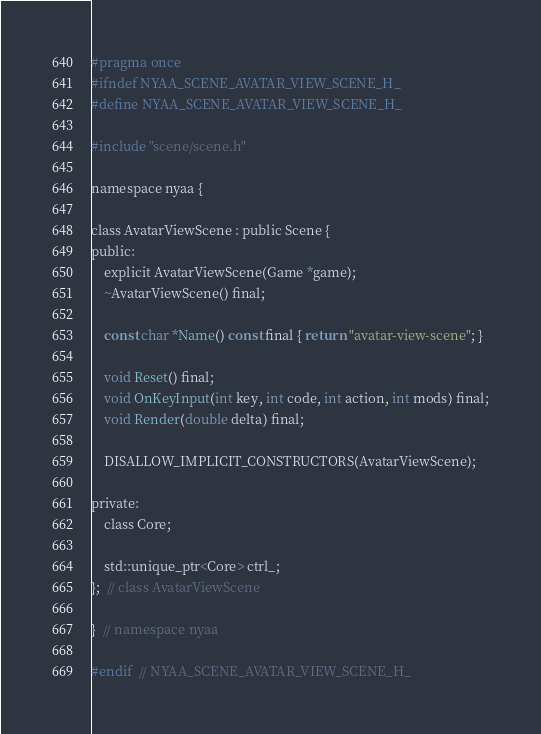<code> <loc_0><loc_0><loc_500><loc_500><_C_>#pragma once
#ifndef NYAA_SCENE_AVATAR_VIEW_SCENE_H_
#define NYAA_SCENE_AVATAR_VIEW_SCENE_H_

#include "scene/scene.h"

namespace nyaa {

class AvatarViewScene : public Scene {
public:
    explicit AvatarViewScene(Game *game);
    ~AvatarViewScene() final;

    const char *Name() const final { return "avatar-view-scene"; }

    void Reset() final;
    void OnKeyInput(int key, int code, int action, int mods) final;
    void Render(double delta) final;

    DISALLOW_IMPLICIT_CONSTRUCTORS(AvatarViewScene);

private:
    class Core;

    std::unique_ptr<Core> ctrl_;
};  // class AvatarViewScene

}  // namespace nyaa

#endif  // NYAA_SCENE_AVATAR_VIEW_SCENE_H_</code> 